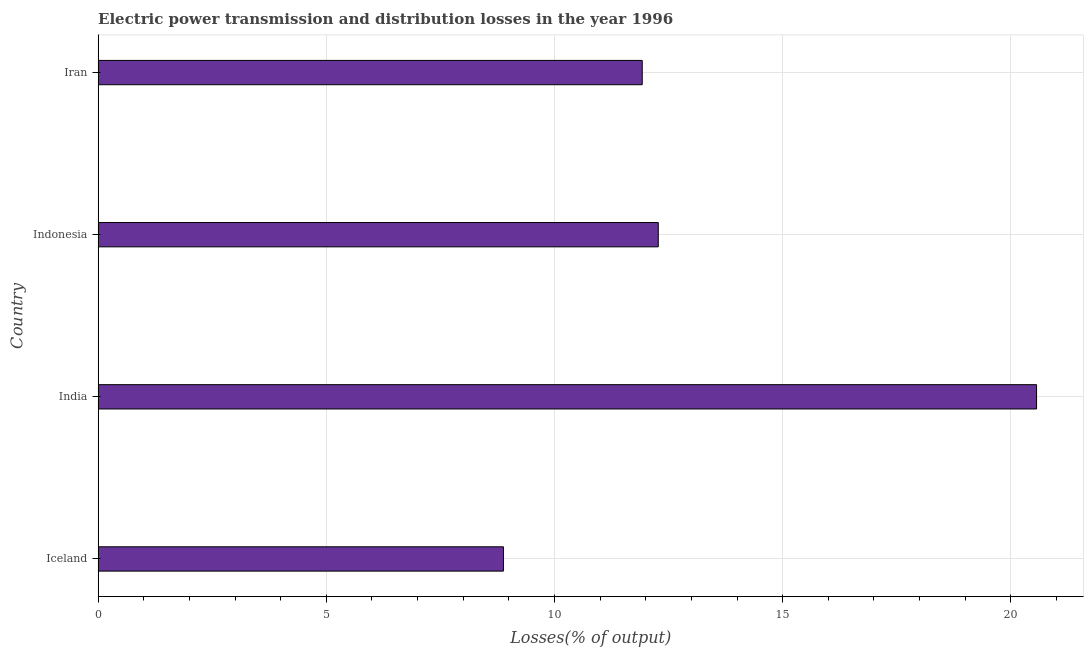Does the graph contain any zero values?
Give a very brief answer. No. Does the graph contain grids?
Offer a very short reply. Yes. What is the title of the graph?
Your answer should be very brief. Electric power transmission and distribution losses in the year 1996. What is the label or title of the X-axis?
Provide a succinct answer. Losses(% of output). What is the label or title of the Y-axis?
Keep it short and to the point. Country. What is the electric power transmission and distribution losses in Iceland?
Offer a very short reply. 8.88. Across all countries, what is the maximum electric power transmission and distribution losses?
Make the answer very short. 20.56. Across all countries, what is the minimum electric power transmission and distribution losses?
Your answer should be compact. 8.88. What is the sum of the electric power transmission and distribution losses?
Provide a short and direct response. 53.64. What is the difference between the electric power transmission and distribution losses in India and Iran?
Ensure brevity in your answer.  8.64. What is the average electric power transmission and distribution losses per country?
Offer a terse response. 13.41. What is the median electric power transmission and distribution losses?
Make the answer very short. 12.1. In how many countries, is the electric power transmission and distribution losses greater than 6 %?
Give a very brief answer. 4. Is the electric power transmission and distribution losses in India less than that in Iran?
Ensure brevity in your answer.  No. Is the difference between the electric power transmission and distribution losses in India and Indonesia greater than the difference between any two countries?
Your answer should be compact. No. What is the difference between the highest and the second highest electric power transmission and distribution losses?
Keep it short and to the point. 8.29. Is the sum of the electric power transmission and distribution losses in India and Iran greater than the maximum electric power transmission and distribution losses across all countries?
Your answer should be very brief. Yes. What is the difference between the highest and the lowest electric power transmission and distribution losses?
Keep it short and to the point. 11.68. How many countries are there in the graph?
Your answer should be compact. 4. What is the difference between two consecutive major ticks on the X-axis?
Provide a succinct answer. 5. Are the values on the major ticks of X-axis written in scientific E-notation?
Your answer should be compact. No. What is the Losses(% of output) in Iceland?
Provide a short and direct response. 8.88. What is the Losses(% of output) of India?
Your response must be concise. 20.56. What is the Losses(% of output) in Indonesia?
Make the answer very short. 12.27. What is the Losses(% of output) in Iran?
Ensure brevity in your answer.  11.92. What is the difference between the Losses(% of output) in Iceland and India?
Provide a succinct answer. -11.68. What is the difference between the Losses(% of output) in Iceland and Indonesia?
Provide a succinct answer. -3.39. What is the difference between the Losses(% of output) in Iceland and Iran?
Offer a terse response. -3.04. What is the difference between the Losses(% of output) in India and Indonesia?
Offer a very short reply. 8.29. What is the difference between the Losses(% of output) in India and Iran?
Ensure brevity in your answer.  8.64. What is the difference between the Losses(% of output) in Indonesia and Iran?
Your answer should be very brief. 0.35. What is the ratio of the Losses(% of output) in Iceland to that in India?
Ensure brevity in your answer.  0.43. What is the ratio of the Losses(% of output) in Iceland to that in Indonesia?
Offer a very short reply. 0.72. What is the ratio of the Losses(% of output) in Iceland to that in Iran?
Make the answer very short. 0.74. What is the ratio of the Losses(% of output) in India to that in Indonesia?
Your answer should be very brief. 1.68. What is the ratio of the Losses(% of output) in India to that in Iran?
Your answer should be compact. 1.73. 